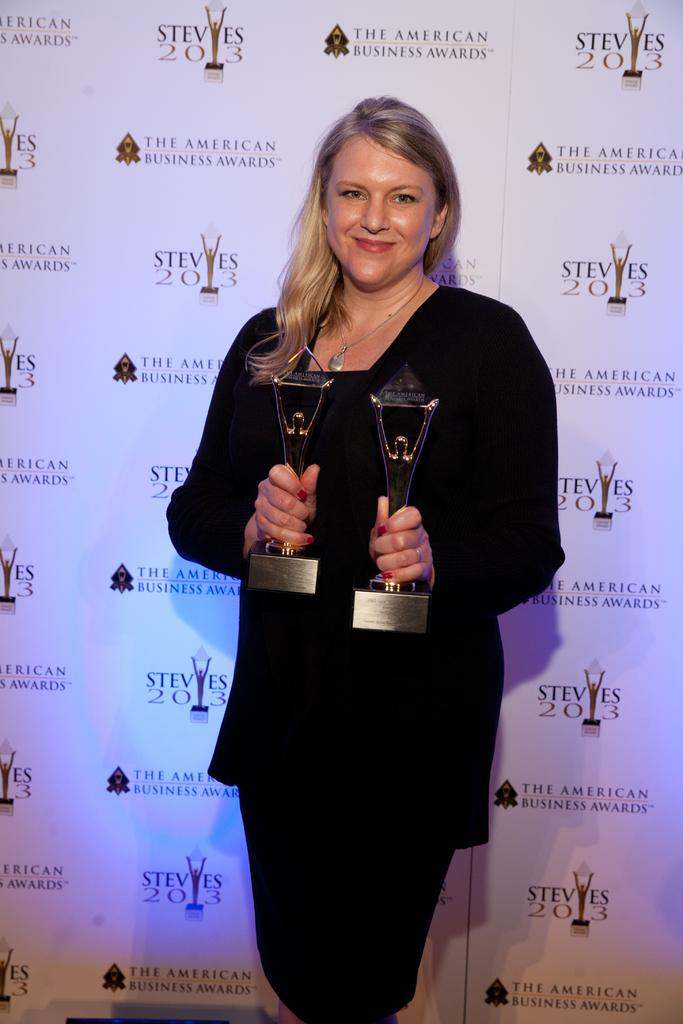Who is the main subject in the image? There is a lady in the image. What is the lady holding in her hands? The lady is holding awards in her hands. What can be seen in the background of the image? There is a banner in the background of the image. What is written on the banner? There is text on the banner. How many cats are sitting on the awards in the image? There are no cats present in the image; the lady is holding awards in her hands. What type of honey is being used to decorate the banner in the image? There is no honey present in the image; the banner has text on it. 